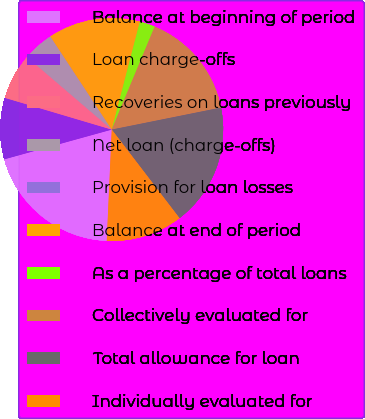Convert chart. <chart><loc_0><loc_0><loc_500><loc_500><pie_chart><fcel>Balance at beginning of period<fcel>Loan charge-offs<fcel>Recoveries on loans previously<fcel>Net loan (charge-offs)<fcel>Provision for loan losses<fcel>Balance at end of period<fcel>As a percentage of total loans<fcel>Collectively evaluated for<fcel>Total allowance for loan<fcel>Individually evaluated for<nl><fcel>19.99%<fcel>8.89%<fcel>6.67%<fcel>4.45%<fcel>0.01%<fcel>13.33%<fcel>2.23%<fcel>15.55%<fcel>17.77%<fcel>11.11%<nl></chart> 